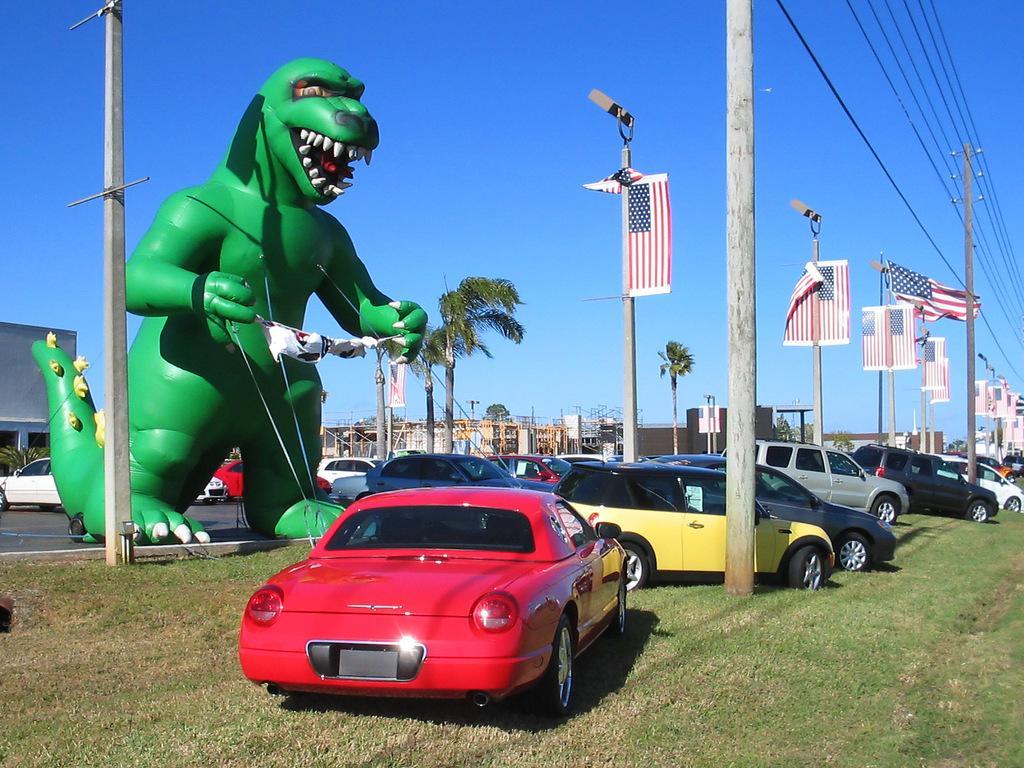In one or two sentences, can you explain what this image depicts? In this image in the foreground there are some vehicles, poles, at the top there is the sky, in the middle there is a dragon image trees, vehicles, poles, flags, buildings visible. 